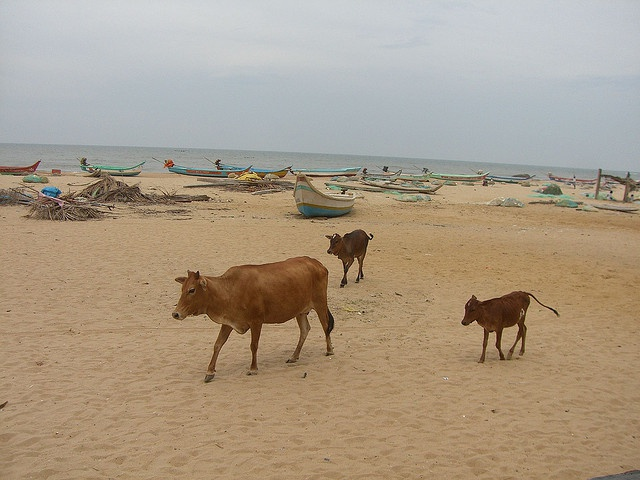Describe the objects in this image and their specific colors. I can see cow in lightgray, maroon, brown, and tan tones, cow in lightgray, maroon, black, and tan tones, boat in lightgray, darkgray, tan, and gray tones, boat in lightgray, gray, and olive tones, and cow in lightgray, maroon, black, and tan tones in this image. 